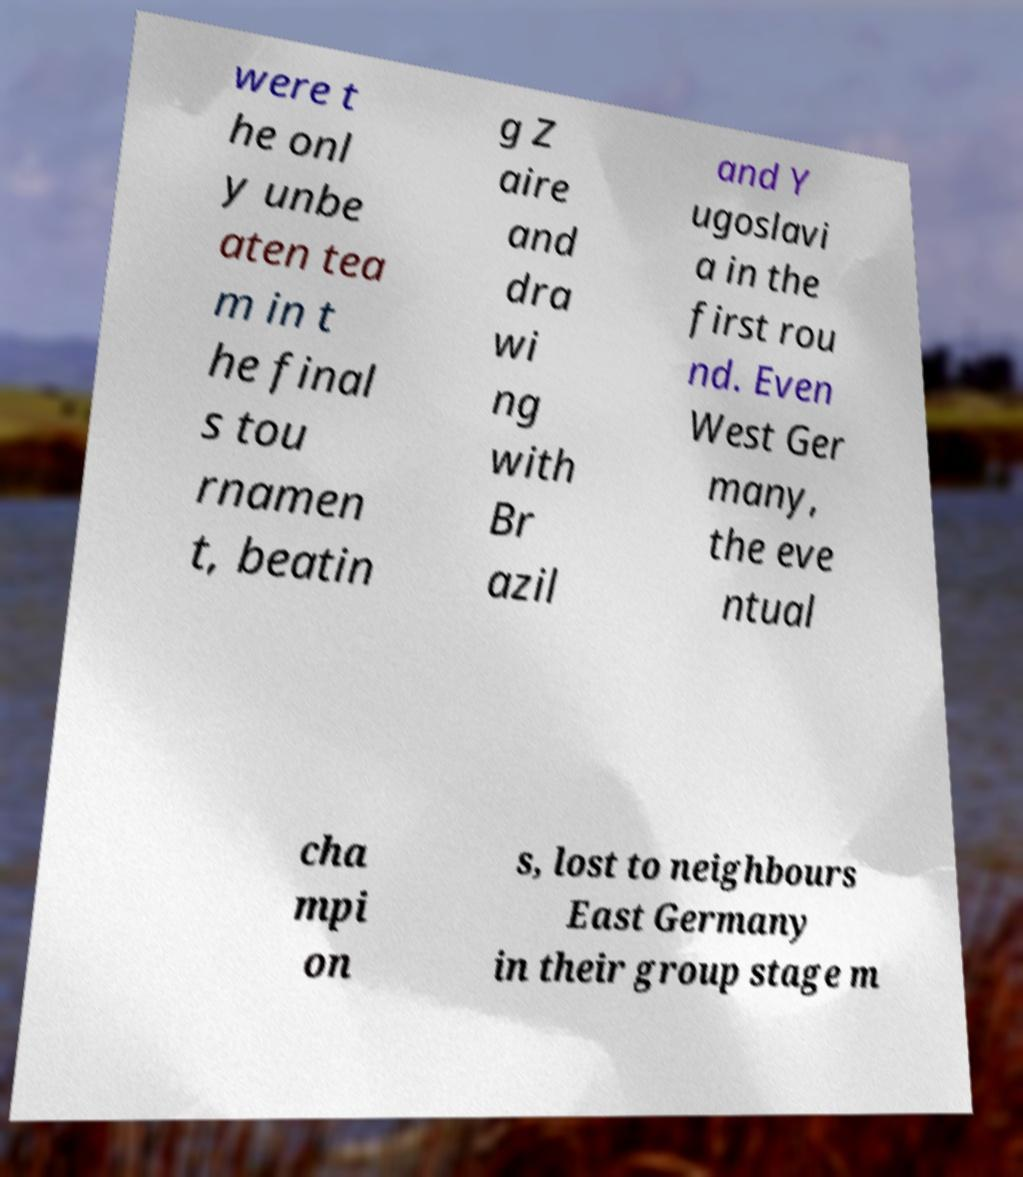What messages or text are displayed in this image? I need them in a readable, typed format. were t he onl y unbe aten tea m in t he final s tou rnamen t, beatin g Z aire and dra wi ng with Br azil and Y ugoslavi a in the first rou nd. Even West Ger many, the eve ntual cha mpi on s, lost to neighbours East Germany in their group stage m 